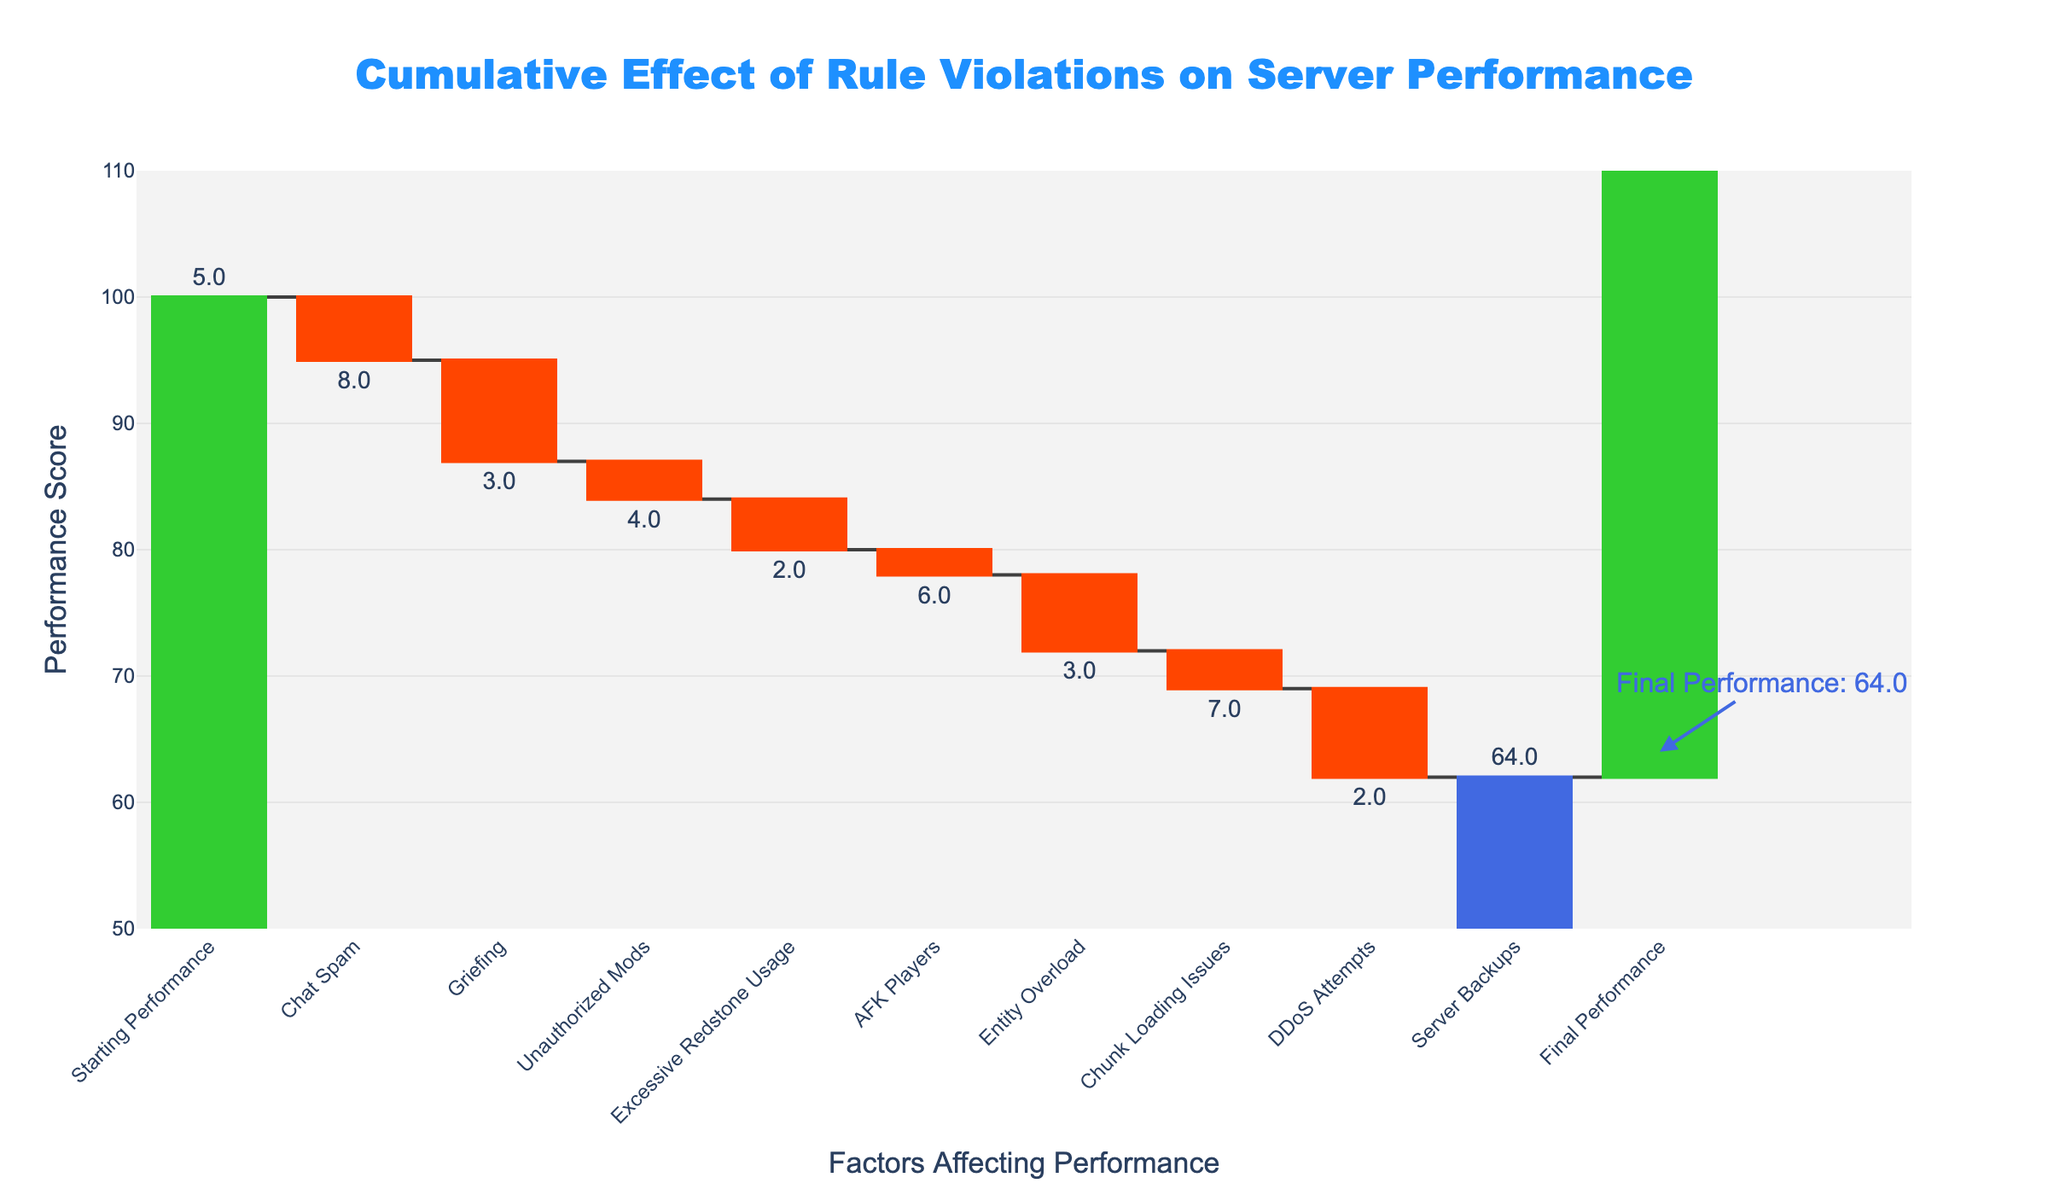What is the title of the Waterfall Chart? The title is prominently displayed at the top of the chart. It reads "Cumulative Effect of Rule Violations on Server Performance".
Answer: Cumulative Effect of Rule Violations on Server Performance What is the starting performance score of the server? The "Starting Performance" bar is labeled with the score at its height, which is indicated as 100.
Answer: 100 How much did "Chat Spam" impact the server performance? By looking at the label for the "Chat Spam" bar and the value displayed above it, we can see that it has a negative impact of 5.
Answer: -5 Which rule violation had the largest negative impact on server performance? By examining all the bars representing rule violations and their values, "DDoS Attempts" shows the largest drop with a value of -7.
Answer: DDoS Attempts How much does "Server Backups" contribute to improving server performance? The "Server Backups" bar, which is green to indicate a positive influence, shows a value of +2.
Answer: +2 What is the server's final performance score after accounting for all rule violations and interventions? The final performance score is displayed at the end of the chart and annotated as 64.
Answer: 64 By how much did "Griefing" and "Entity Overload" combined reduce the server performance? Adding their values, "Griefing" (-8) and "Entity Overload" (-6), results in a combined reduction of -14.
Answer: -14 What was the cumulative negative impact of all rule violations before any positive adjustments? Summing up the negative impacts: -5 (Chat Spam) - 8 (Griefing) - 3 (Unauthorized Mods) - 4 (Excessive Redstone Usage) - 2 (AFK Players) - 6 (Entity Overload) - 3 (Chunk Loading Issues) - 7 (DDoS Attempts), the total is -38.
Answer: -38 What was the numerical increase in performance due to "Server Backups"? The "Server Backups" bar shows a positive value of +2, which indicates that server backups contributed an improvement of 2 points.
Answer: 2 